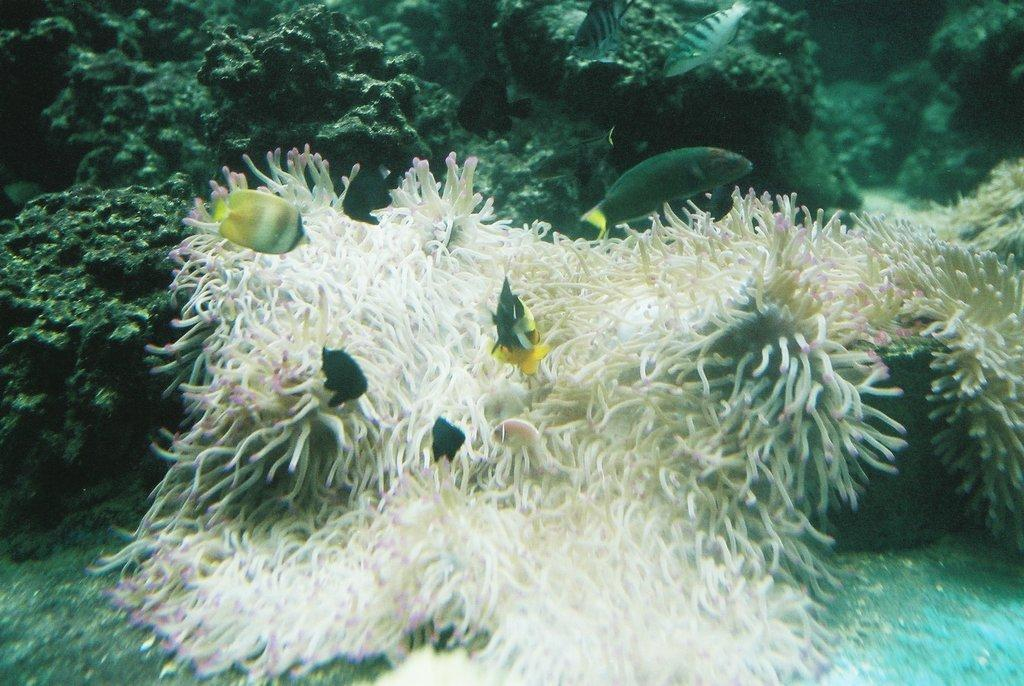What type of creature is present in the image? There is a creature in the image, but its specific type cannot be determined from the provided facts. What other living organisms are present in the image? There are fishes in the image. What environment are the creatures and fishes in? The creatures and fishes are surviving inside the water. What type of oatmeal is being prepared in the image? There is no oatmeal present in the image; it features a creature and fishes surviving inside the water. 